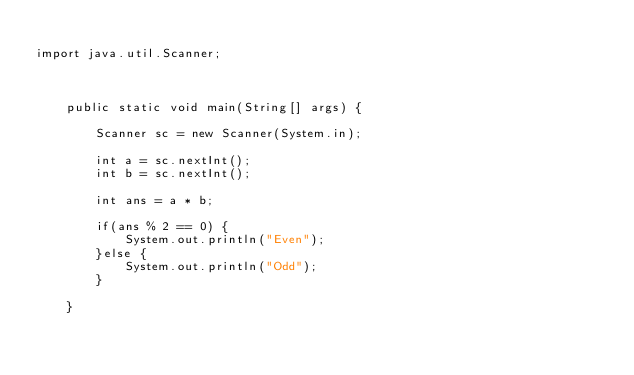<code> <loc_0><loc_0><loc_500><loc_500><_Java_>
import java.util.Scanner;



	public static void main(String[] args) {
		
		Scanner sc = new Scanner(System.in);
		
		int a = sc.nextInt();
		int b = sc.nextInt();
		
		int ans = a * b;
		
		if(ans % 2 == 0) {
			System.out.println("Even");
		}else {
			System.out.println("Odd");
		}
		
	}


</code> 